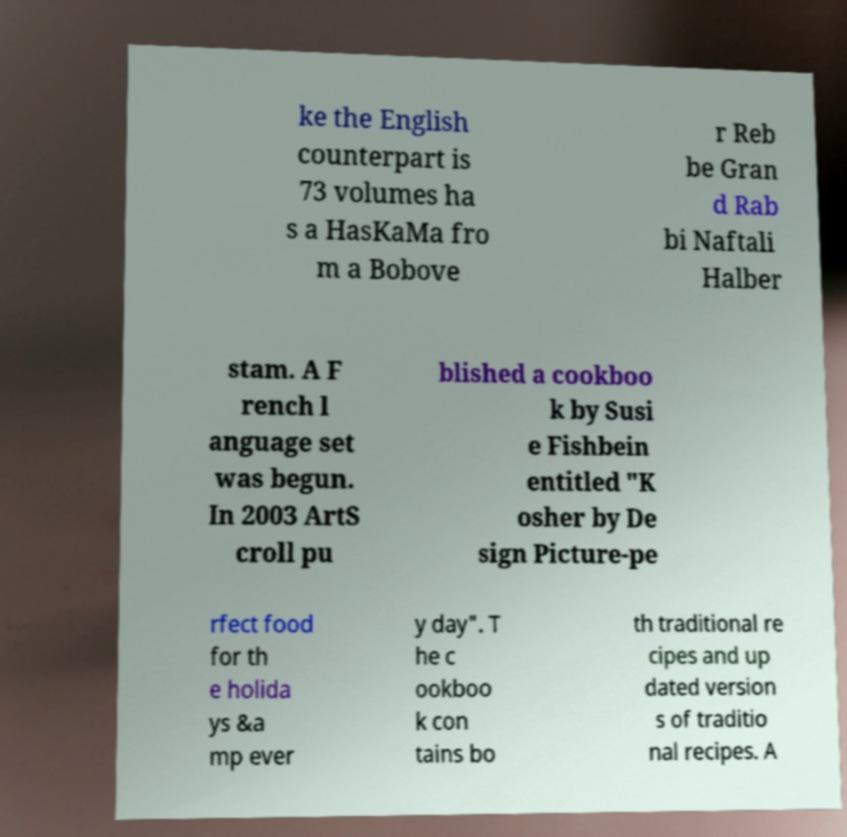I need the written content from this picture converted into text. Can you do that? ke the English counterpart is 73 volumes ha s a HasKaMa fro m a Bobove r Reb be Gran d Rab bi Naftali Halber stam. A F rench l anguage set was begun. In 2003 ArtS croll pu blished a cookboo k by Susi e Fishbein entitled "K osher by De sign Picture-pe rfect food for th e holida ys &a mp ever y day". T he c ookboo k con tains bo th traditional re cipes and up dated version s of traditio nal recipes. A 